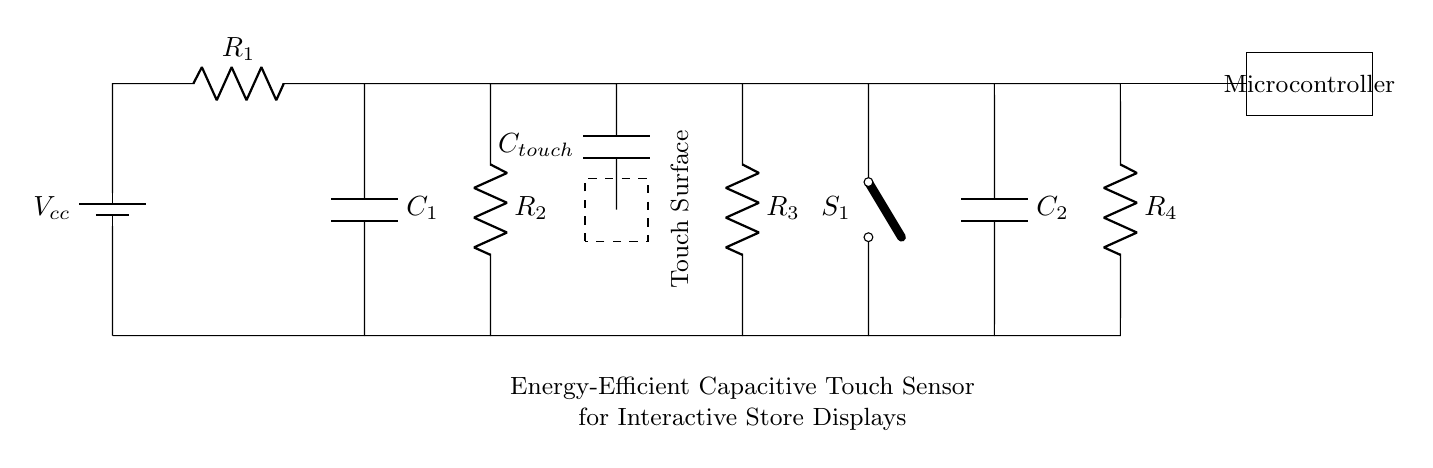What is the value of the capacitor labeled C1? The value is not specified in the circuit diagram, as component values are typically annotated. However, it will be determined based on the design requirements of the touch sensor.
Answer: Not specified What component is represented by R3? R3 is a resistor, which is typically used to limit current in the circuit or to create a voltage divider.
Answer: Resistor How many resistors are in this circuit? There are four resistors in the circuit: R1, R2, R3, and R4.
Answer: Four What does the dashed rectangle represent? The dashed rectangle represents the touch surface area of the capacitive touch sensor, where users interact with the display.
Answer: Touch surface What is the role of the capacitor labeled Ctouch? Ctouch functions as the sensing element of the capacitive touch sensor, detecting changes in capacitance when touched.
Answer: Sensing element What type of switch is used in this circuit? The switch S1 is a cute open switch, indicating it is designed to control the connection in the circuit, typically for enabling or disabling the touch sensing feature.
Answer: Cute open switch If each resistor has a value of 1k ohm, what is the total resistance seen by C1? To find the total resistance, we need to consider R1, R2, R3, and R4, which are all in series. The total resistance is calculated by summing the individual resistances: 1k + 1k + 1k + 1k = 4k ohm.
Answer: 4k ohm 